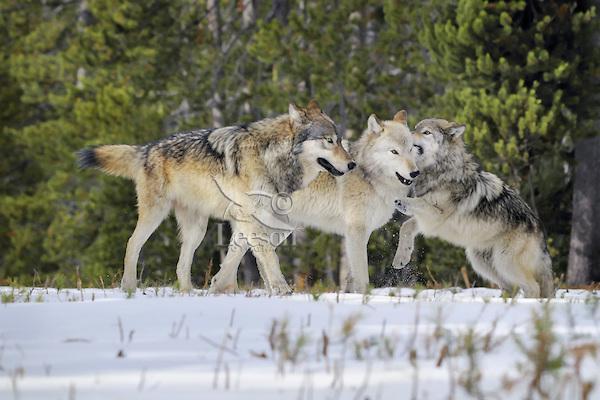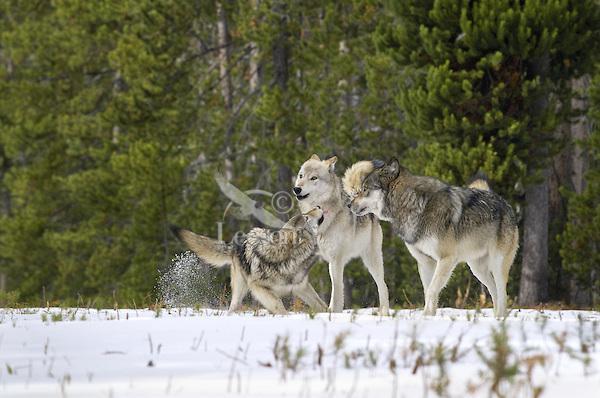The first image is the image on the left, the second image is the image on the right. Assess this claim about the two images: "The right image contains exactly two wolves.". Correct or not? Answer yes or no. No. The first image is the image on the left, the second image is the image on the right. Analyze the images presented: Is the assertion "In each image, multiple wolves interact playfully on a snowy field in front of evergreens." valid? Answer yes or no. Yes. 